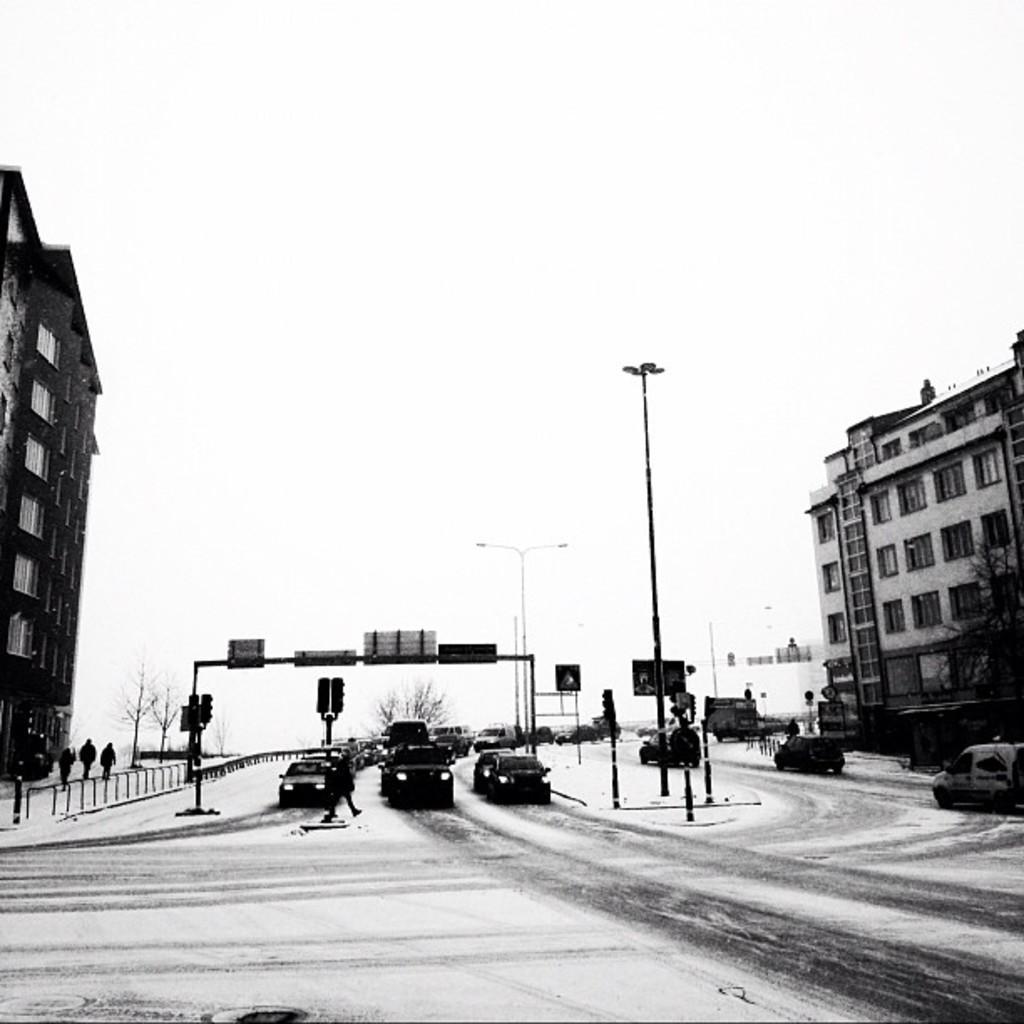Describe this image in one or two sentences. In this image, we can see few vehicles are on the roads. Here we can see traffic signals, poles, lights, boards, buildings, tree. Here there are few people. Background there is a sky. 